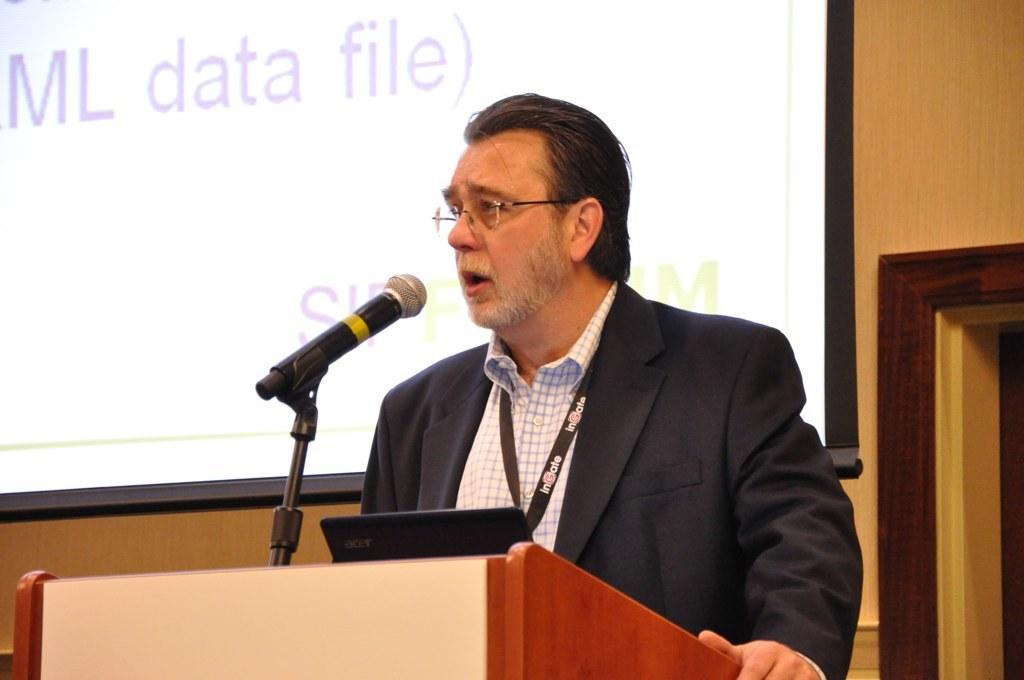In one or two sentences, can you explain what this image depicts? In this image there is a man standing in front of a podium, on that podium there is laptop and a mic, in the background there is a wooden wall to that wall there is a screen projection. 